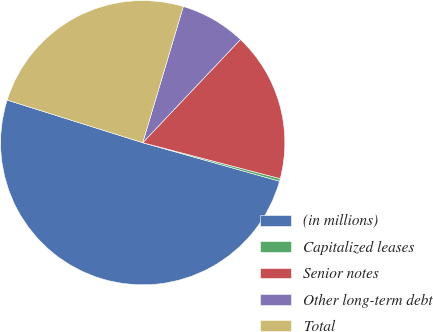<chart> <loc_0><loc_0><loc_500><loc_500><pie_chart><fcel>(in millions)<fcel>Capitalized leases<fcel>Senior notes<fcel>Other long-term debt<fcel>Total<nl><fcel>50.48%<fcel>0.3%<fcel>17.0%<fcel>7.46%<fcel>24.76%<nl></chart> 